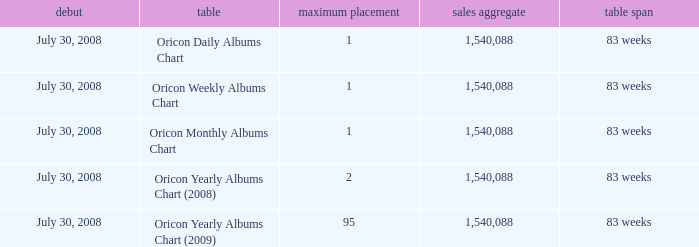Which Chart has a Peak Position of 1? Oricon Daily Albums Chart, Oricon Weekly Albums Chart, Oricon Monthly Albums Chart. 